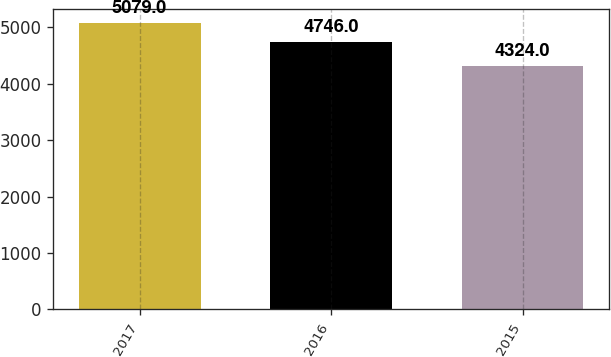Convert chart. <chart><loc_0><loc_0><loc_500><loc_500><bar_chart><fcel>2017<fcel>2016<fcel>2015<nl><fcel>5079<fcel>4746<fcel>4324<nl></chart> 